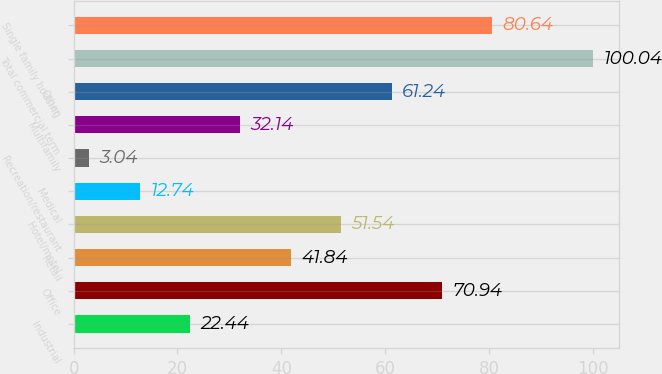Convert chart to OTSL. <chart><loc_0><loc_0><loc_500><loc_500><bar_chart><fcel>Industrial<fcel>Office<fcel>Retail<fcel>Hotel/motel<fcel>Medical<fcel>Recreation/restaurant<fcel>Multifamily<fcel>Other<fcel>Total commercial term<fcel>Single family housing<nl><fcel>22.44<fcel>70.94<fcel>41.84<fcel>51.54<fcel>12.74<fcel>3.04<fcel>32.14<fcel>61.24<fcel>100.04<fcel>80.64<nl></chart> 